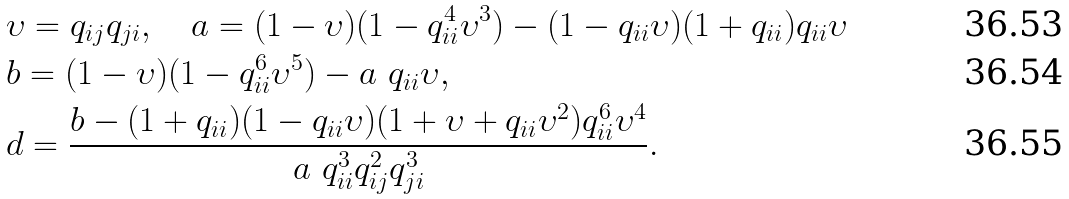Convert formula to latex. <formula><loc_0><loc_0><loc_500><loc_500>& \upsilon = q _ { i j } q _ { j i } , \quad a = ( 1 - \upsilon ) ( 1 - q _ { i i } ^ { 4 } \upsilon ^ { 3 } ) - ( 1 - q _ { i i } \upsilon ) ( 1 + q _ { i i } ) q _ { i i } \upsilon \\ & b = ( 1 - \upsilon ) ( 1 - q _ { i i } ^ { 6 } \upsilon ^ { 5 } ) - a \ q _ { i i } \upsilon , \\ & d = \frac { b - ( 1 + q _ { i i } ) ( 1 - q _ { i i } \upsilon ) ( 1 + \upsilon + q _ { i i } \upsilon ^ { 2 } ) q _ { i i } ^ { 6 } \upsilon ^ { 4 } } { a \ q _ { i i } ^ { 3 } q _ { i j } ^ { 2 } q _ { j i } ^ { 3 } } .</formula> 